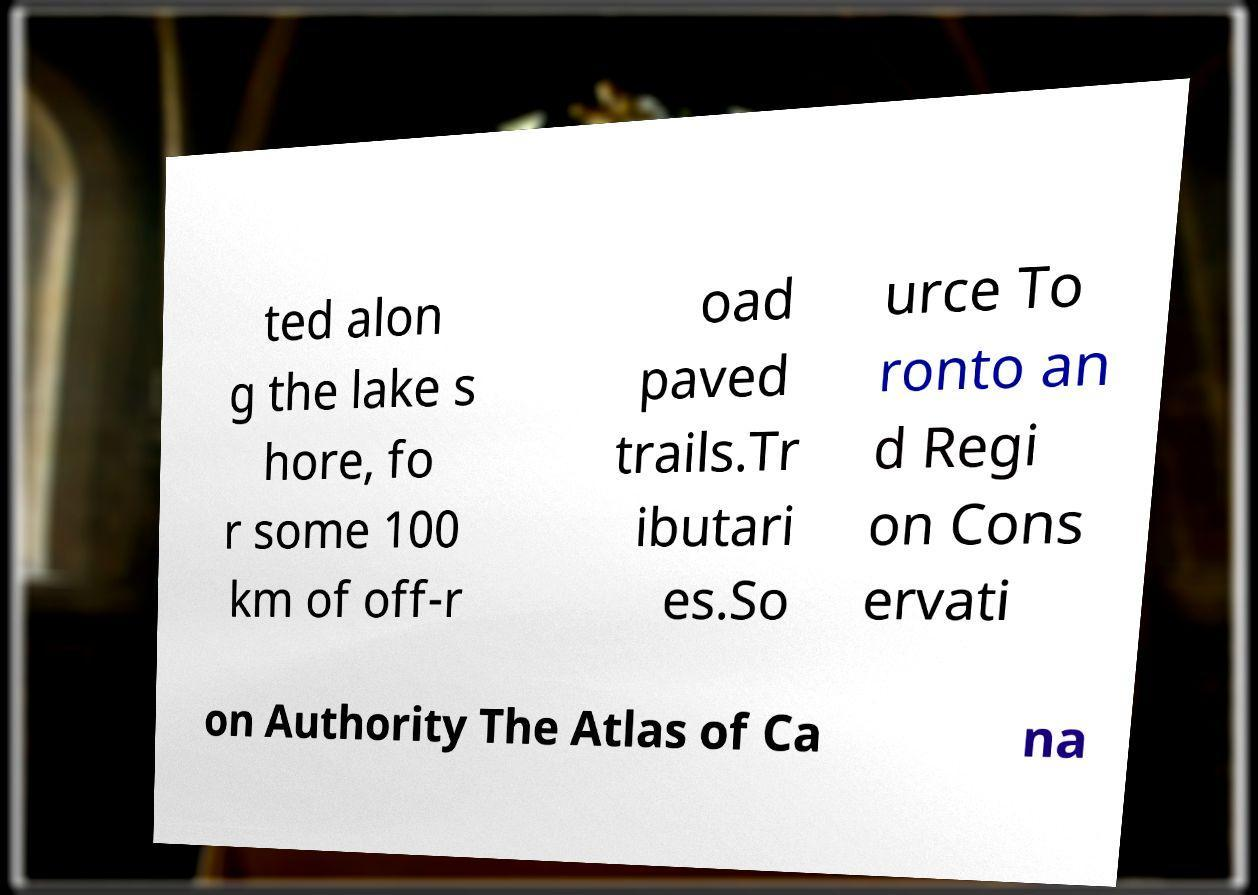Can you read and provide the text displayed in the image?This photo seems to have some interesting text. Can you extract and type it out for me? ted alon g the lake s hore, fo r some 100 km of off-r oad paved trails.Tr ibutari es.So urce To ronto an d Regi on Cons ervati on Authority The Atlas of Ca na 